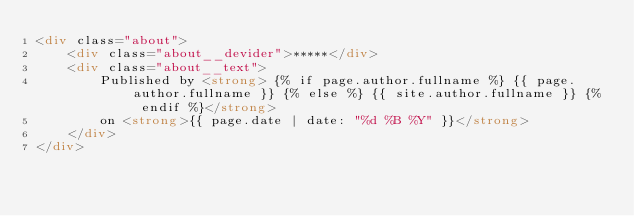Convert code to text. <code><loc_0><loc_0><loc_500><loc_500><_HTML_><div class="about">
    <div class="about__devider">*****</div>
    <div class="about__text">
        Published by <strong> {% if page.author.fullname %} {{ page.author.fullname }} {% else %} {{ site.author.fullname }} {% endif %}</strong>
        on <strong>{{ page.date | date: "%d %B %Y" }}</strong>
    </div>
</div>
</code> 